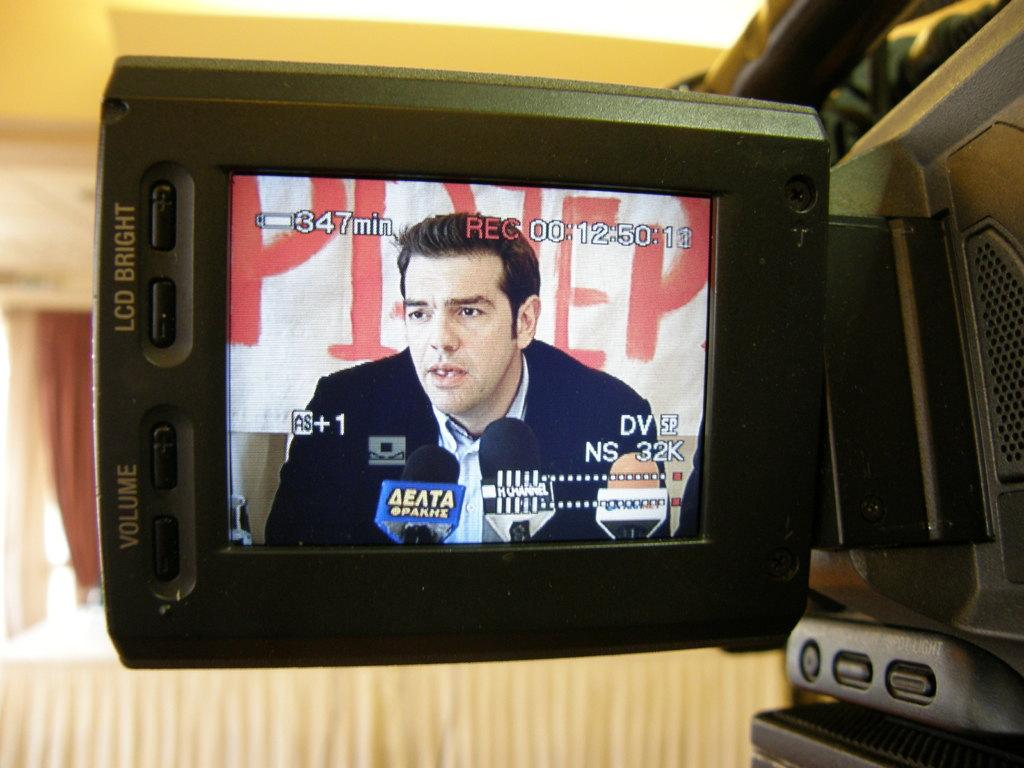<image>
Present a compact description of the photo's key features. 347 minutes of battery time are remaining on this recorder. 